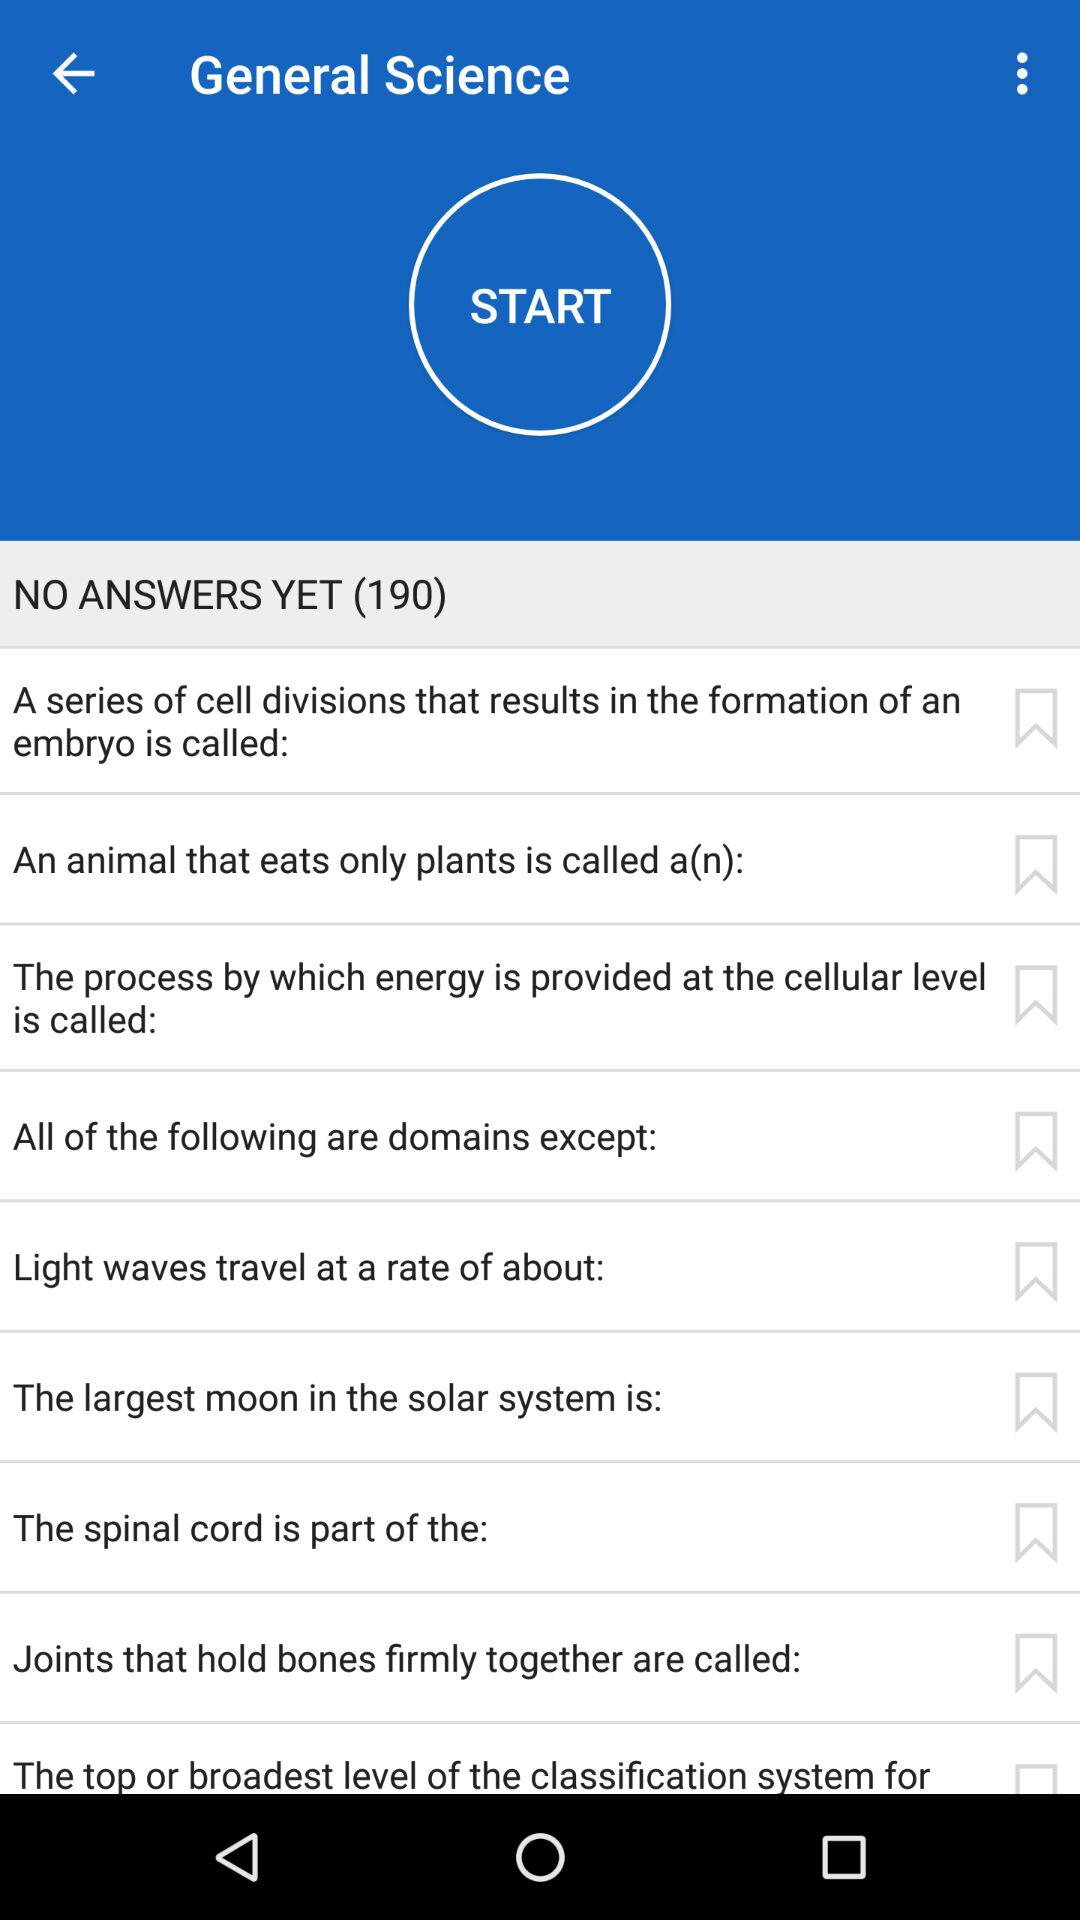How much time is allowed to complete one answer?
When the provided information is insufficient, respond with <no answer>. <no answer> 